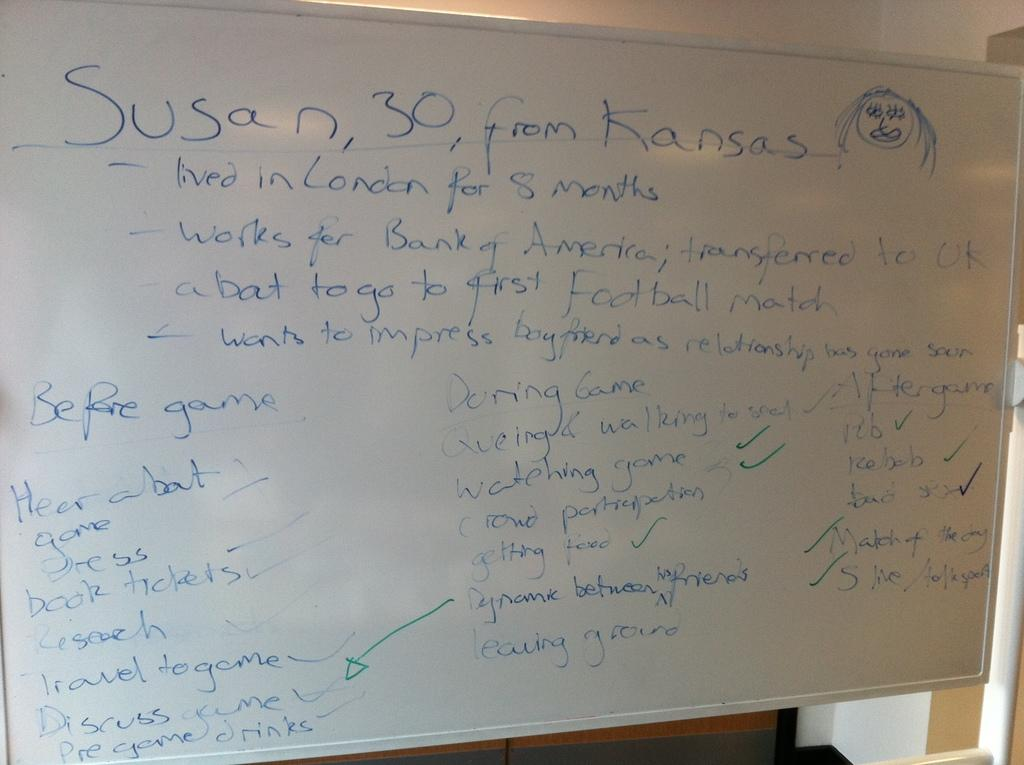<image>
Render a clear and concise summary of the photo. White board which starts off by saying "Susan from Kansas". 